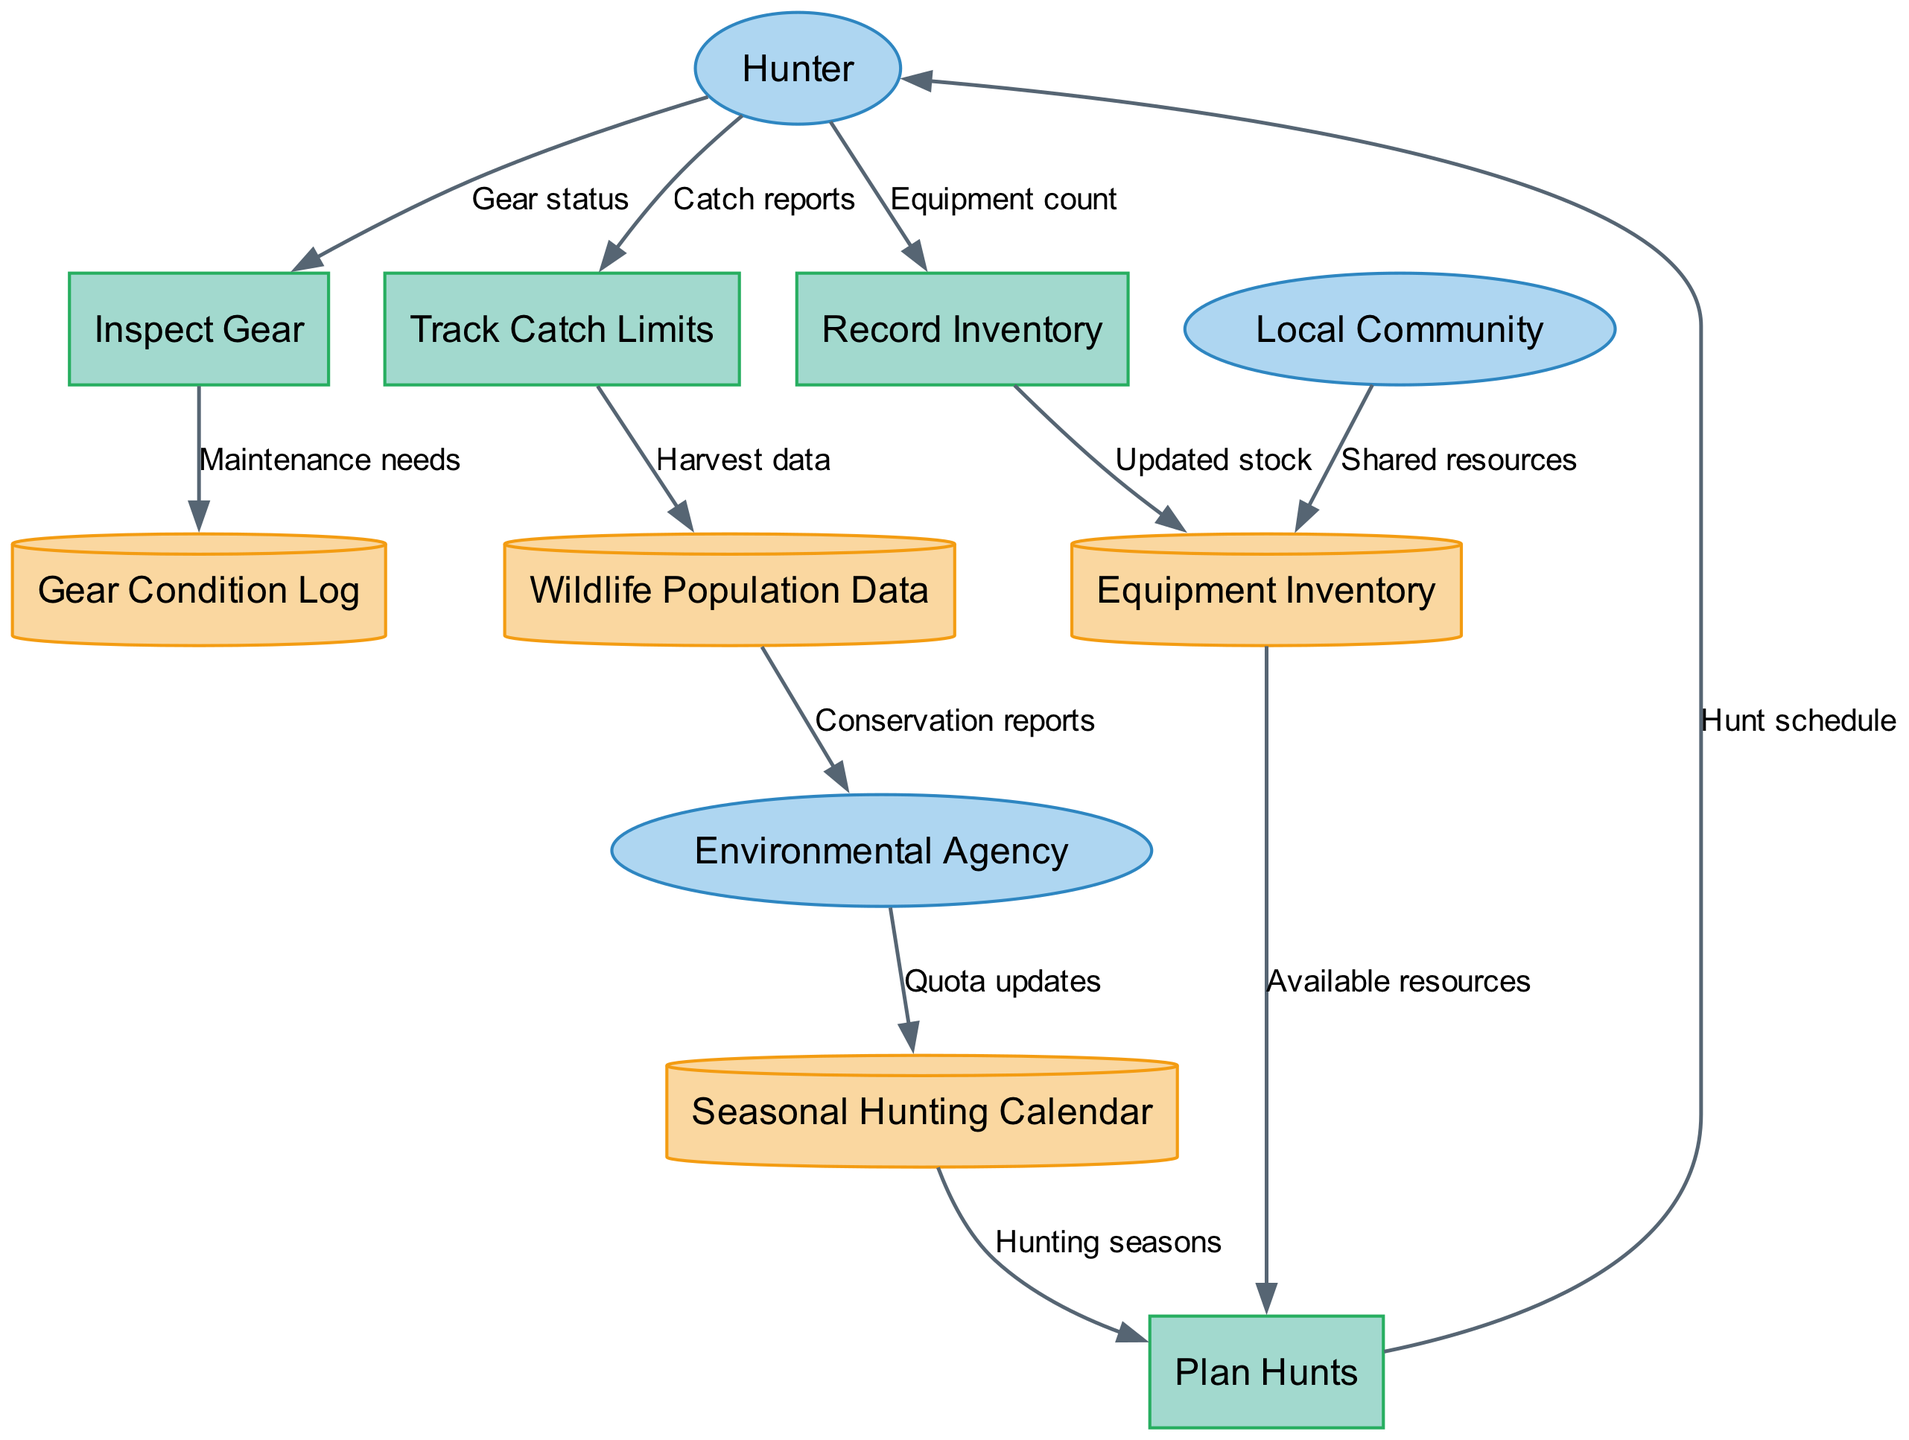What are the external entities in the diagram? The external entities are depicted as blue ellipses in the diagram. They include "Hunter," "Local Community," and "Environmental Agency."
Answer: Hunter, Local Community, Environmental Agency How many processes are shown in the diagram? The diagram includes processes represented by green rectangles. By counting them, we find there are four processes: "Inspect Gear," "Record Inventory," "Plan Hunts," and "Track Catch Limits."
Answer: 4 What data flow comes from the "Hunter" to "Inspect Gear"? The data flow from "Hunter" to "Inspect Gear" is labeled "Gear status." This shows the information that the hunter provides regarding the condition of the gear.
Answer: Gear status Which data store receives updated stock from "Record Inventory"? The "Record Inventory" process updates the "Equipment Inventory" data store with the latest equipment counts. This flow shows the management of available resources.
Answer: Equipment Inventory What is the relationship between "Track Catch Limits" and "Wildlife Population Data"? The relationship indicates that "Track Catch Limits" sends "Harvest data" to "Wildlife Population Data." This represents the interaction of harvested data impacting wildlife management.
Answer: Harvest data How does the "Environmental Agency" contribute to the "Seasonal Hunting Calendar"? The "Environmental Agency" provides "Quota updates" to the "Seasonal Hunting Calendar," indicating how the agency influences hunting regulations based on ecological assessment.
Answer: Quota updates What is the purpose of the "Plan Hunts" process? The "Plan Hunts" process collects inputs from "Equipment Inventory" and "Seasonal Hunting Calendar" to generate a "Hunt schedule" for the hunter. This shows how planning integrates available resources and seasonal guidance.
Answer: Hunt schedule Which entity is linked to the "Wildlife Population Data" for conservation reports? "Environmental Agency" is the entity that receives "Conservation reports" from "Wildlife Population Data," indicating the importance of monitoring and reporting wildlife status for conservation efforts.
Answer: Environmental Agency How many data stores are present in the diagram? The diagram contains four data stores represented by yellow cylinders: "Gear Condition Log," "Equipment Inventory," "Seasonal Hunting Calendar," and "Wildlife Population Data." Counting these gives us the total.
Answer: 4 